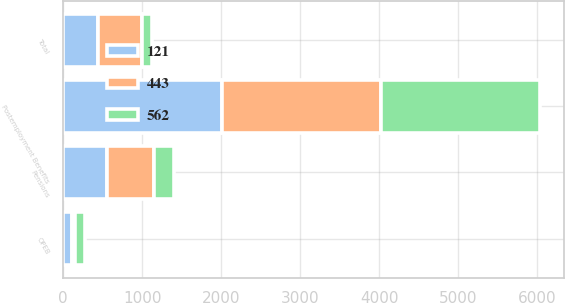Convert chart. <chart><loc_0><loc_0><loc_500><loc_500><stacked_bar_chart><ecel><fcel>Postemployment Benefits<fcel>Pensions<fcel>OPEB<fcel>Total<nl><fcel>443<fcel>2012<fcel>596<fcel>34<fcel>562<nl><fcel>121<fcel>2011<fcel>555<fcel>112<fcel>443<nl><fcel>562<fcel>2010<fcel>247<fcel>126<fcel>121<nl></chart> 